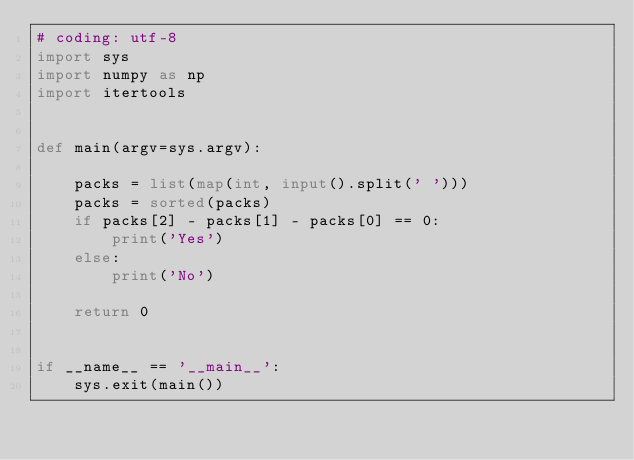<code> <loc_0><loc_0><loc_500><loc_500><_Python_># coding: utf-8
import sys
import numpy as np
import itertools


def main(argv=sys.argv):
  
    packs = list(map(int, input().split(' ')))
    packs = sorted(packs)
    if packs[2] - packs[1] - packs[0] == 0:
        print('Yes')
    else:
        print('No')
  
    return 0


if __name__ == '__main__':
    sys.exit(main())
</code> 